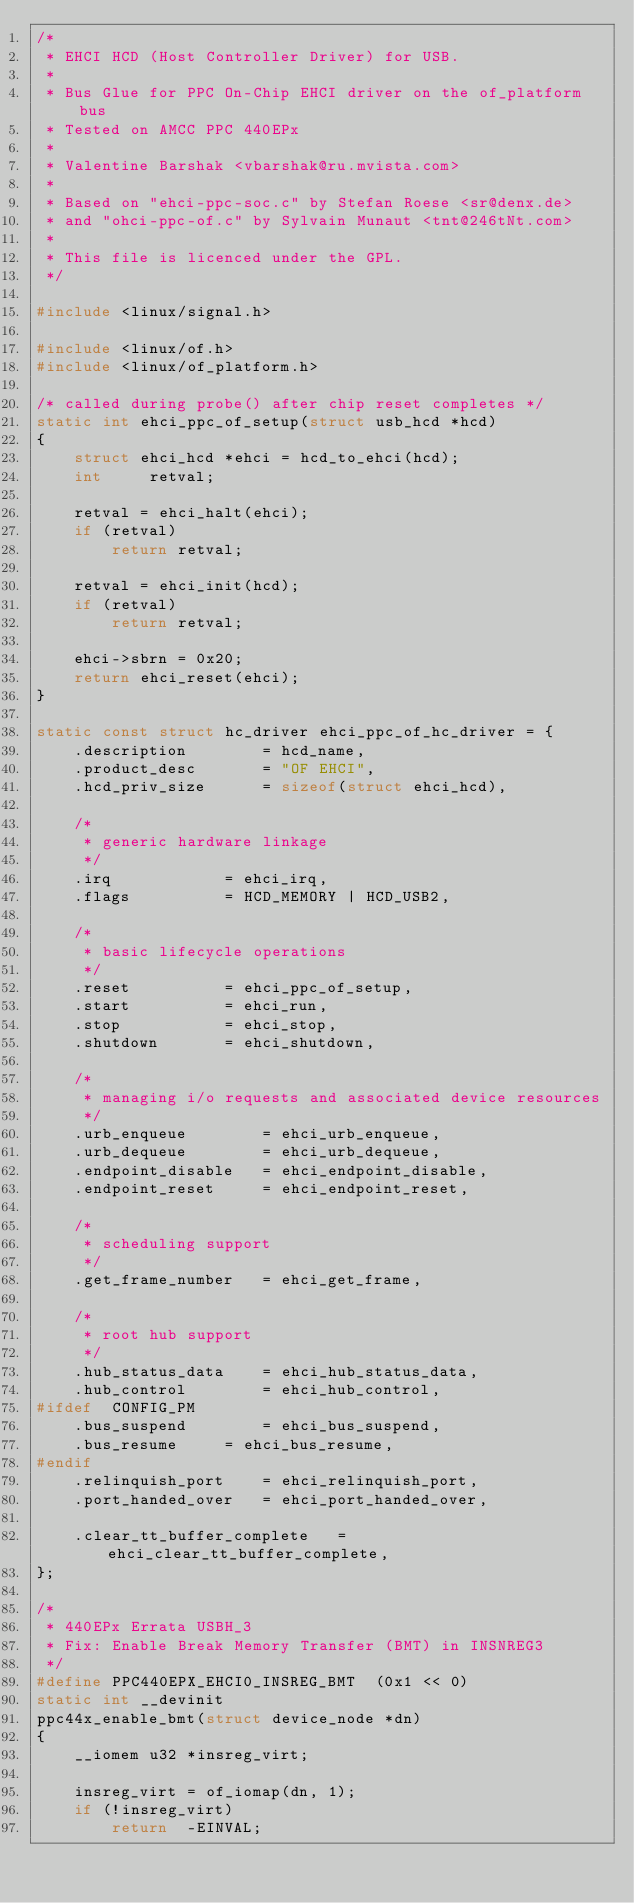Convert code to text. <code><loc_0><loc_0><loc_500><loc_500><_C_>/*
 * EHCI HCD (Host Controller Driver) for USB.
 *
 * Bus Glue for PPC On-Chip EHCI driver on the of_platform bus
 * Tested on AMCC PPC 440EPx
 *
 * Valentine Barshak <vbarshak@ru.mvista.com>
 *
 * Based on "ehci-ppc-soc.c" by Stefan Roese <sr@denx.de>
 * and "ohci-ppc-of.c" by Sylvain Munaut <tnt@246tNt.com>
 *
 * This file is licenced under the GPL.
 */

#include <linux/signal.h>

#include <linux/of.h>
#include <linux/of_platform.h>

/* called during probe() after chip reset completes */
static int ehci_ppc_of_setup(struct usb_hcd *hcd)
{
	struct ehci_hcd	*ehci = hcd_to_ehci(hcd);
	int		retval;

	retval = ehci_halt(ehci);
	if (retval)
		return retval;

	retval = ehci_init(hcd);
	if (retval)
		return retval;

	ehci->sbrn = 0x20;
	return ehci_reset(ehci);
}

static const struct hc_driver ehci_ppc_of_hc_driver = {
	.description		= hcd_name,
	.product_desc		= "OF EHCI",
	.hcd_priv_size		= sizeof(struct ehci_hcd),

	/*
	 * generic hardware linkage
	 */
	.irq			= ehci_irq,
	.flags			= HCD_MEMORY | HCD_USB2,

	/*
	 * basic lifecycle operations
	 */
	.reset			= ehci_ppc_of_setup,
	.start			= ehci_run,
	.stop			= ehci_stop,
	.shutdown		= ehci_shutdown,

	/*
	 * managing i/o requests and associated device resources
	 */
	.urb_enqueue		= ehci_urb_enqueue,
	.urb_dequeue		= ehci_urb_dequeue,
	.endpoint_disable	= ehci_endpoint_disable,
	.endpoint_reset		= ehci_endpoint_reset,

	/*
	 * scheduling support
	 */
	.get_frame_number	= ehci_get_frame,

	/*
	 * root hub support
	 */
	.hub_status_data	= ehci_hub_status_data,
	.hub_control		= ehci_hub_control,
#ifdef	CONFIG_PM
	.bus_suspend		= ehci_bus_suspend,
	.bus_resume		= ehci_bus_resume,
#endif
	.relinquish_port	= ehci_relinquish_port,
	.port_handed_over	= ehci_port_handed_over,

	.clear_tt_buffer_complete	= ehci_clear_tt_buffer_complete,
};

/*
 * 440EPx Errata USBH_3
 * Fix: Enable Break Memory Transfer (BMT) in INSNREG3
 */
#define PPC440EPX_EHCI0_INSREG_BMT	(0x1 << 0)
static int __devinit
ppc44x_enable_bmt(struct device_node *dn)
{
	__iomem u32 *insreg_virt;

	insreg_virt = of_iomap(dn, 1);
	if (!insreg_virt)
		return  -EINVAL;
</code> 